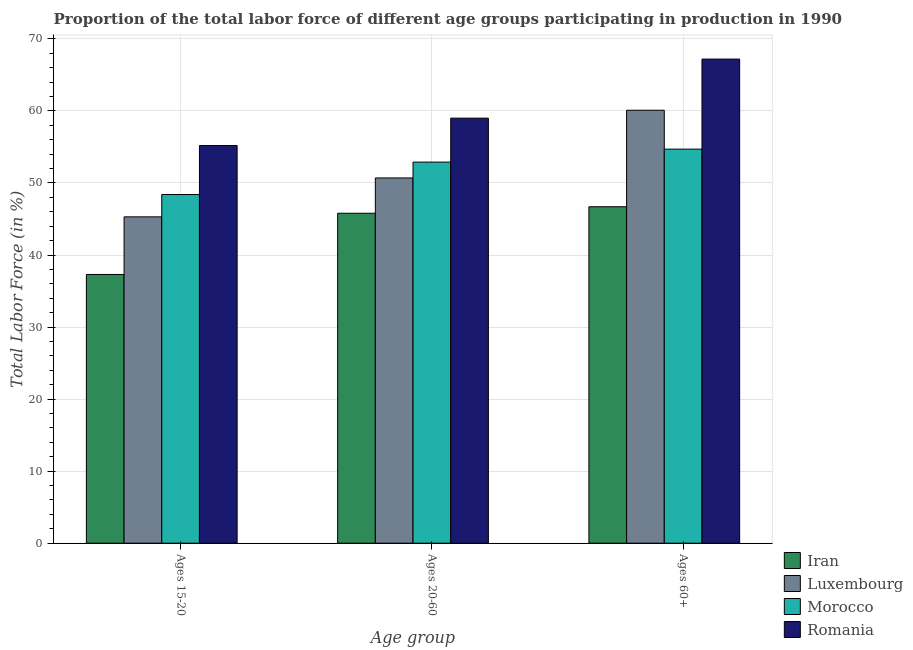How many different coloured bars are there?
Your response must be concise. 4. How many bars are there on the 2nd tick from the left?
Your answer should be compact. 4. How many bars are there on the 2nd tick from the right?
Provide a short and direct response. 4. What is the label of the 1st group of bars from the left?
Give a very brief answer. Ages 15-20. What is the percentage of labor force within the age group 20-60 in Morocco?
Your response must be concise. 52.9. Across all countries, what is the maximum percentage of labor force above age 60?
Make the answer very short. 67.2. Across all countries, what is the minimum percentage of labor force above age 60?
Your response must be concise. 46.7. In which country was the percentage of labor force within the age group 20-60 maximum?
Keep it short and to the point. Romania. In which country was the percentage of labor force within the age group 15-20 minimum?
Your answer should be compact. Iran. What is the total percentage of labor force within the age group 15-20 in the graph?
Keep it short and to the point. 186.2. What is the difference between the percentage of labor force within the age group 20-60 in Morocco and that in Iran?
Keep it short and to the point. 7.1. What is the difference between the percentage of labor force within the age group 20-60 in Morocco and the percentage of labor force above age 60 in Romania?
Provide a succinct answer. -14.3. What is the average percentage of labor force within the age group 20-60 per country?
Make the answer very short. 52.1. What is the difference between the percentage of labor force within the age group 15-20 and percentage of labor force above age 60 in Romania?
Make the answer very short. -12. In how many countries, is the percentage of labor force within the age group 20-60 greater than 14 %?
Offer a very short reply. 4. What is the ratio of the percentage of labor force within the age group 20-60 in Morocco to that in Iran?
Offer a terse response. 1.16. Is the percentage of labor force within the age group 20-60 in Romania less than that in Morocco?
Give a very brief answer. No. What is the difference between the highest and the second highest percentage of labor force above age 60?
Your response must be concise. 7.1. What is the difference between the highest and the lowest percentage of labor force within the age group 20-60?
Give a very brief answer. 13.2. In how many countries, is the percentage of labor force within the age group 20-60 greater than the average percentage of labor force within the age group 20-60 taken over all countries?
Keep it short and to the point. 2. Is the sum of the percentage of labor force above age 60 in Iran and Romania greater than the maximum percentage of labor force within the age group 20-60 across all countries?
Keep it short and to the point. Yes. What does the 3rd bar from the left in Ages 15-20 represents?
Provide a succinct answer. Morocco. What does the 4th bar from the right in Ages 15-20 represents?
Your response must be concise. Iran. How many bars are there?
Provide a succinct answer. 12. Are all the bars in the graph horizontal?
Your response must be concise. No. How many countries are there in the graph?
Make the answer very short. 4. What is the difference between two consecutive major ticks on the Y-axis?
Make the answer very short. 10. Does the graph contain any zero values?
Make the answer very short. No. Where does the legend appear in the graph?
Provide a succinct answer. Bottom right. How are the legend labels stacked?
Keep it short and to the point. Vertical. What is the title of the graph?
Provide a succinct answer. Proportion of the total labor force of different age groups participating in production in 1990. What is the label or title of the X-axis?
Your answer should be compact. Age group. What is the label or title of the Y-axis?
Your response must be concise. Total Labor Force (in %). What is the Total Labor Force (in %) of Iran in Ages 15-20?
Your answer should be compact. 37.3. What is the Total Labor Force (in %) in Luxembourg in Ages 15-20?
Offer a very short reply. 45.3. What is the Total Labor Force (in %) of Morocco in Ages 15-20?
Your answer should be very brief. 48.4. What is the Total Labor Force (in %) of Romania in Ages 15-20?
Your response must be concise. 55.2. What is the Total Labor Force (in %) of Iran in Ages 20-60?
Provide a succinct answer. 45.8. What is the Total Labor Force (in %) of Luxembourg in Ages 20-60?
Ensure brevity in your answer.  50.7. What is the Total Labor Force (in %) in Morocco in Ages 20-60?
Your answer should be compact. 52.9. What is the Total Labor Force (in %) in Iran in Ages 60+?
Offer a very short reply. 46.7. What is the Total Labor Force (in %) of Luxembourg in Ages 60+?
Make the answer very short. 60.1. What is the Total Labor Force (in %) of Morocco in Ages 60+?
Your answer should be very brief. 54.7. What is the Total Labor Force (in %) in Romania in Ages 60+?
Provide a succinct answer. 67.2. Across all Age group, what is the maximum Total Labor Force (in %) in Iran?
Give a very brief answer. 46.7. Across all Age group, what is the maximum Total Labor Force (in %) of Luxembourg?
Offer a very short reply. 60.1. Across all Age group, what is the maximum Total Labor Force (in %) of Morocco?
Provide a succinct answer. 54.7. Across all Age group, what is the maximum Total Labor Force (in %) of Romania?
Provide a succinct answer. 67.2. Across all Age group, what is the minimum Total Labor Force (in %) in Iran?
Provide a short and direct response. 37.3. Across all Age group, what is the minimum Total Labor Force (in %) in Luxembourg?
Ensure brevity in your answer.  45.3. Across all Age group, what is the minimum Total Labor Force (in %) in Morocco?
Offer a very short reply. 48.4. Across all Age group, what is the minimum Total Labor Force (in %) in Romania?
Provide a short and direct response. 55.2. What is the total Total Labor Force (in %) in Iran in the graph?
Make the answer very short. 129.8. What is the total Total Labor Force (in %) in Luxembourg in the graph?
Make the answer very short. 156.1. What is the total Total Labor Force (in %) in Morocco in the graph?
Your answer should be very brief. 156. What is the total Total Labor Force (in %) of Romania in the graph?
Give a very brief answer. 181.4. What is the difference between the Total Labor Force (in %) in Iran in Ages 15-20 and that in Ages 20-60?
Give a very brief answer. -8.5. What is the difference between the Total Labor Force (in %) in Luxembourg in Ages 15-20 and that in Ages 20-60?
Offer a terse response. -5.4. What is the difference between the Total Labor Force (in %) of Luxembourg in Ages 15-20 and that in Ages 60+?
Your response must be concise. -14.8. What is the difference between the Total Labor Force (in %) in Iran in Ages 20-60 and that in Ages 60+?
Make the answer very short. -0.9. What is the difference between the Total Labor Force (in %) in Luxembourg in Ages 20-60 and that in Ages 60+?
Your response must be concise. -9.4. What is the difference between the Total Labor Force (in %) of Iran in Ages 15-20 and the Total Labor Force (in %) of Morocco in Ages 20-60?
Your answer should be compact. -15.6. What is the difference between the Total Labor Force (in %) of Iran in Ages 15-20 and the Total Labor Force (in %) of Romania in Ages 20-60?
Provide a succinct answer. -21.7. What is the difference between the Total Labor Force (in %) in Luxembourg in Ages 15-20 and the Total Labor Force (in %) in Morocco in Ages 20-60?
Your response must be concise. -7.6. What is the difference between the Total Labor Force (in %) in Luxembourg in Ages 15-20 and the Total Labor Force (in %) in Romania in Ages 20-60?
Offer a terse response. -13.7. What is the difference between the Total Labor Force (in %) of Morocco in Ages 15-20 and the Total Labor Force (in %) of Romania in Ages 20-60?
Your response must be concise. -10.6. What is the difference between the Total Labor Force (in %) in Iran in Ages 15-20 and the Total Labor Force (in %) in Luxembourg in Ages 60+?
Your answer should be compact. -22.8. What is the difference between the Total Labor Force (in %) in Iran in Ages 15-20 and the Total Labor Force (in %) in Morocco in Ages 60+?
Ensure brevity in your answer.  -17.4. What is the difference between the Total Labor Force (in %) in Iran in Ages 15-20 and the Total Labor Force (in %) in Romania in Ages 60+?
Your answer should be very brief. -29.9. What is the difference between the Total Labor Force (in %) of Luxembourg in Ages 15-20 and the Total Labor Force (in %) of Morocco in Ages 60+?
Give a very brief answer. -9.4. What is the difference between the Total Labor Force (in %) of Luxembourg in Ages 15-20 and the Total Labor Force (in %) of Romania in Ages 60+?
Give a very brief answer. -21.9. What is the difference between the Total Labor Force (in %) of Morocco in Ages 15-20 and the Total Labor Force (in %) of Romania in Ages 60+?
Provide a short and direct response. -18.8. What is the difference between the Total Labor Force (in %) in Iran in Ages 20-60 and the Total Labor Force (in %) in Luxembourg in Ages 60+?
Your answer should be compact. -14.3. What is the difference between the Total Labor Force (in %) of Iran in Ages 20-60 and the Total Labor Force (in %) of Morocco in Ages 60+?
Offer a terse response. -8.9. What is the difference between the Total Labor Force (in %) of Iran in Ages 20-60 and the Total Labor Force (in %) of Romania in Ages 60+?
Keep it short and to the point. -21.4. What is the difference between the Total Labor Force (in %) in Luxembourg in Ages 20-60 and the Total Labor Force (in %) in Morocco in Ages 60+?
Your answer should be very brief. -4. What is the difference between the Total Labor Force (in %) in Luxembourg in Ages 20-60 and the Total Labor Force (in %) in Romania in Ages 60+?
Your response must be concise. -16.5. What is the difference between the Total Labor Force (in %) of Morocco in Ages 20-60 and the Total Labor Force (in %) of Romania in Ages 60+?
Your answer should be very brief. -14.3. What is the average Total Labor Force (in %) of Iran per Age group?
Provide a short and direct response. 43.27. What is the average Total Labor Force (in %) of Luxembourg per Age group?
Give a very brief answer. 52.03. What is the average Total Labor Force (in %) of Romania per Age group?
Your response must be concise. 60.47. What is the difference between the Total Labor Force (in %) in Iran and Total Labor Force (in %) in Luxembourg in Ages 15-20?
Your response must be concise. -8. What is the difference between the Total Labor Force (in %) of Iran and Total Labor Force (in %) of Morocco in Ages 15-20?
Make the answer very short. -11.1. What is the difference between the Total Labor Force (in %) of Iran and Total Labor Force (in %) of Romania in Ages 15-20?
Offer a very short reply. -17.9. What is the difference between the Total Labor Force (in %) in Luxembourg and Total Labor Force (in %) in Morocco in Ages 15-20?
Offer a very short reply. -3.1. What is the difference between the Total Labor Force (in %) in Luxembourg and Total Labor Force (in %) in Romania in Ages 15-20?
Keep it short and to the point. -9.9. What is the difference between the Total Labor Force (in %) of Iran and Total Labor Force (in %) of Luxembourg in Ages 20-60?
Your answer should be very brief. -4.9. What is the difference between the Total Labor Force (in %) of Luxembourg and Total Labor Force (in %) of Morocco in Ages 20-60?
Make the answer very short. -2.2. What is the difference between the Total Labor Force (in %) in Iran and Total Labor Force (in %) in Luxembourg in Ages 60+?
Your response must be concise. -13.4. What is the difference between the Total Labor Force (in %) in Iran and Total Labor Force (in %) in Romania in Ages 60+?
Your answer should be compact. -20.5. What is the difference between the Total Labor Force (in %) of Luxembourg and Total Labor Force (in %) of Morocco in Ages 60+?
Keep it short and to the point. 5.4. What is the ratio of the Total Labor Force (in %) in Iran in Ages 15-20 to that in Ages 20-60?
Give a very brief answer. 0.81. What is the ratio of the Total Labor Force (in %) of Luxembourg in Ages 15-20 to that in Ages 20-60?
Your answer should be very brief. 0.89. What is the ratio of the Total Labor Force (in %) of Morocco in Ages 15-20 to that in Ages 20-60?
Your response must be concise. 0.91. What is the ratio of the Total Labor Force (in %) of Romania in Ages 15-20 to that in Ages 20-60?
Offer a terse response. 0.94. What is the ratio of the Total Labor Force (in %) in Iran in Ages 15-20 to that in Ages 60+?
Make the answer very short. 0.8. What is the ratio of the Total Labor Force (in %) in Luxembourg in Ages 15-20 to that in Ages 60+?
Offer a very short reply. 0.75. What is the ratio of the Total Labor Force (in %) in Morocco in Ages 15-20 to that in Ages 60+?
Keep it short and to the point. 0.88. What is the ratio of the Total Labor Force (in %) of Romania in Ages 15-20 to that in Ages 60+?
Your answer should be very brief. 0.82. What is the ratio of the Total Labor Force (in %) of Iran in Ages 20-60 to that in Ages 60+?
Provide a succinct answer. 0.98. What is the ratio of the Total Labor Force (in %) of Luxembourg in Ages 20-60 to that in Ages 60+?
Offer a very short reply. 0.84. What is the ratio of the Total Labor Force (in %) in Morocco in Ages 20-60 to that in Ages 60+?
Ensure brevity in your answer.  0.97. What is the ratio of the Total Labor Force (in %) of Romania in Ages 20-60 to that in Ages 60+?
Ensure brevity in your answer.  0.88. What is the difference between the highest and the second highest Total Labor Force (in %) in Morocco?
Provide a short and direct response. 1.8. What is the difference between the highest and the lowest Total Labor Force (in %) of Romania?
Offer a very short reply. 12. 